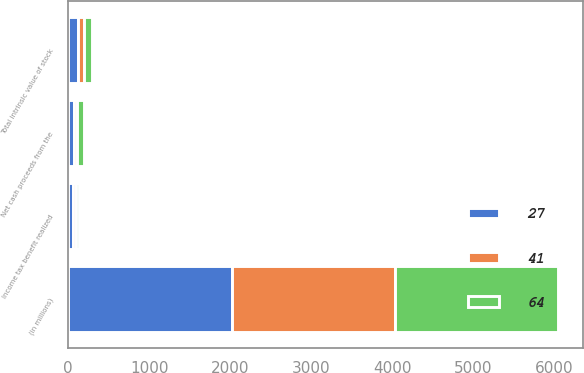Convert chart. <chart><loc_0><loc_0><loc_500><loc_500><stacked_bar_chart><ecel><fcel>(in millions)<fcel>Net cash proceeds from the<fcel>Total intrinsic value of stock<fcel>Income tax benefit realized<nl><fcel>41<fcel>2018<fcel>34<fcel>77<fcel>27<nl><fcel>27<fcel>2017<fcel>75<fcel>118<fcel>64<nl><fcel>64<fcel>2016<fcel>88<fcel>95<fcel>41<nl></chart> 